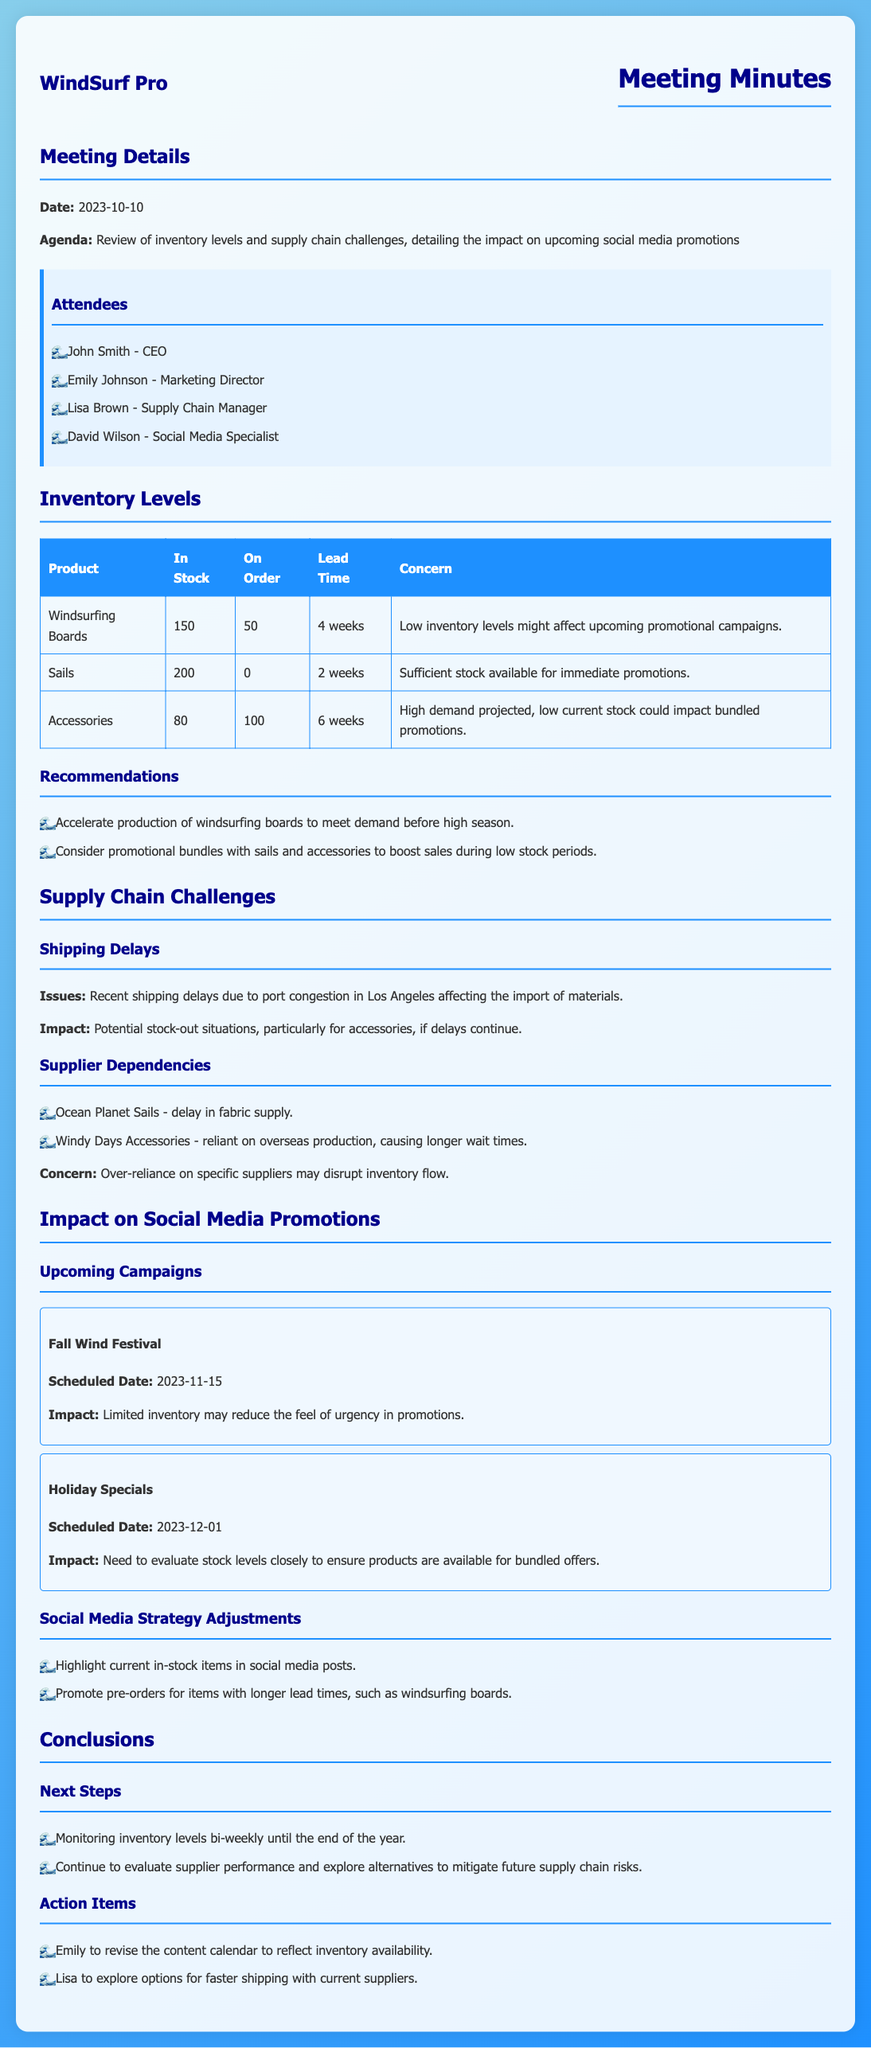what is the date of the meeting? The meeting took place on October 10, 2023.
Answer: October 10, 2023 how many windsurfing boards are in stock? The document states that there are 150 windsurfing boards in stock.
Answer: 150 what is the lead time for sails? The lead time for sails is mentioned as 2 weeks.
Answer: 2 weeks what potential concern is highlighted for accessories? The concern for accessories is that high demand projected, low current stock could impact bundled promotions.
Answer: High demand projected, low current stock could impact bundled promotions what scheduled date is the Fall Wind Festival? The Fall Wind Festival is scheduled for November 15, 2023.
Answer: November 15, 2023 what recommendation was made regarding windsurfing boards? The recommendation made was to accelerate production of windsurfing boards to meet demand before high season.
Answer: Accelerate production of windsurfing boards to meet demand before high season who is responsible for revising the content calendar? Emily is responsible for revising the content calendar.
Answer: Emily what specific issue is causing shipping delays? The specific issue causing shipping delays is port congestion in Los Angeles.
Answer: Port congestion in Los Angeles what is the inventory level of accessories? The inventory level for accessories is 80.
Answer: 80 